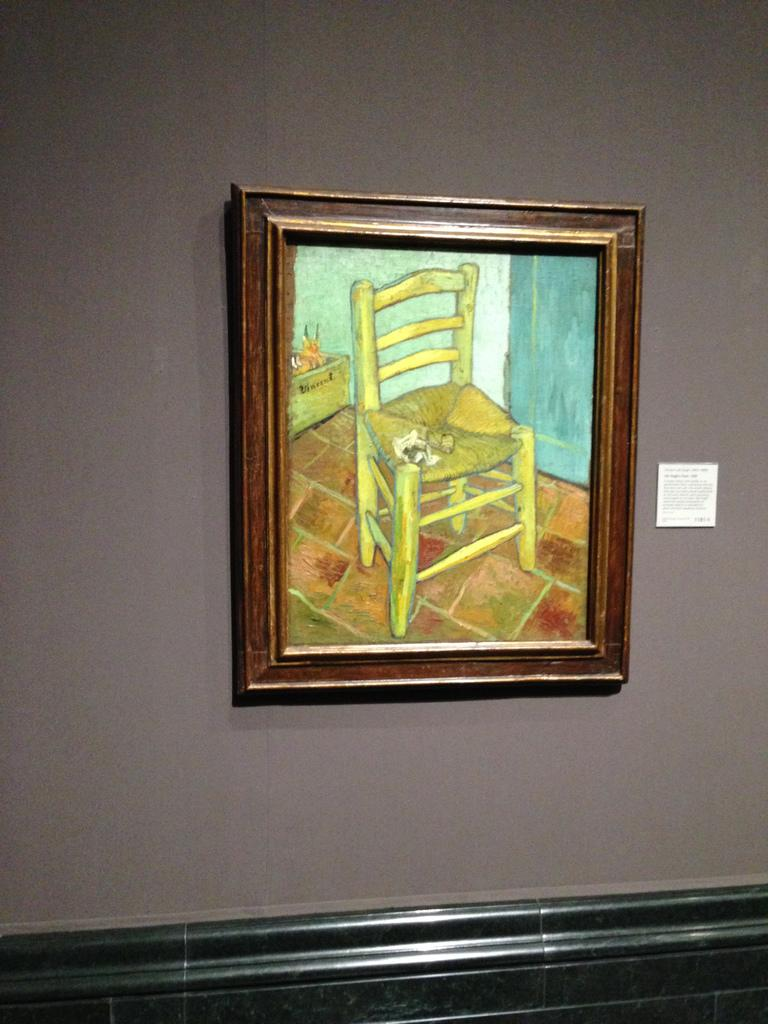What is hanging on the wall in the image? There is a photo frame on the wall. What is depicted inside the photo frame? The photo frame contains a picture of a chair. How many legs can be seen on the chair in the photo frame? There are no legs visible on the chair in the photo frame, as it is a two-dimensional image of a chair. 